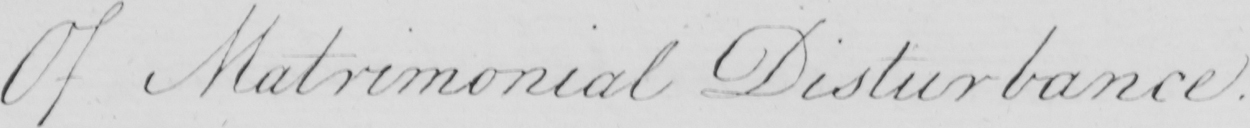Please transcribe the handwritten text in this image. Of Matrimonial Disturbance . 